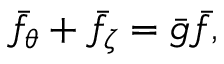Convert formula to latex. <formula><loc_0><loc_0><loc_500><loc_500>\bar { f } _ { \theta } + \bar { f } _ { \zeta } = \bar { g } \bar { f } ,</formula> 